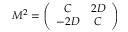<formula> <loc_0><loc_0><loc_500><loc_500>M ^ { 2 } = \left ( \begin{array} { c c } { C } & { 2 D } \\ { - 2 D } & { C } \end{array} \right )</formula> 